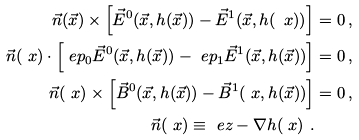<formula> <loc_0><loc_0><loc_500><loc_500>\vec { n } ( \vec { x } ) \times \left [ \vec { E } ^ { 0 } ( \vec { x } , h ( \vec { x } ) ) - \vec { E } ^ { 1 } ( \vec { x } , h ( \ x ) ) \right ] & = 0 \, , \\ \vec { n } ( \ x ) \cdot \left [ \ e p _ { 0 } \vec { E } ^ { 0 } ( \vec { x } , h ( \vec { x } ) ) - \ e p _ { 1 } \vec { E } ^ { 1 } ( \vec { x } , h ( \vec { x } ) ) \right ] & = 0 \, , \\ \vec { n } ( \ x ) \times \left [ \vec { B } ^ { 0 } ( \vec { x } , h ( \vec { x } ) ) - \vec { B } ^ { 1 } ( \ x , h ( \vec { x } ) ) \right ] & = 0 \, , \\ \vec { n } ( \ x ) \equiv \ e z - \nabla h ( \ x ) \ . &</formula> 